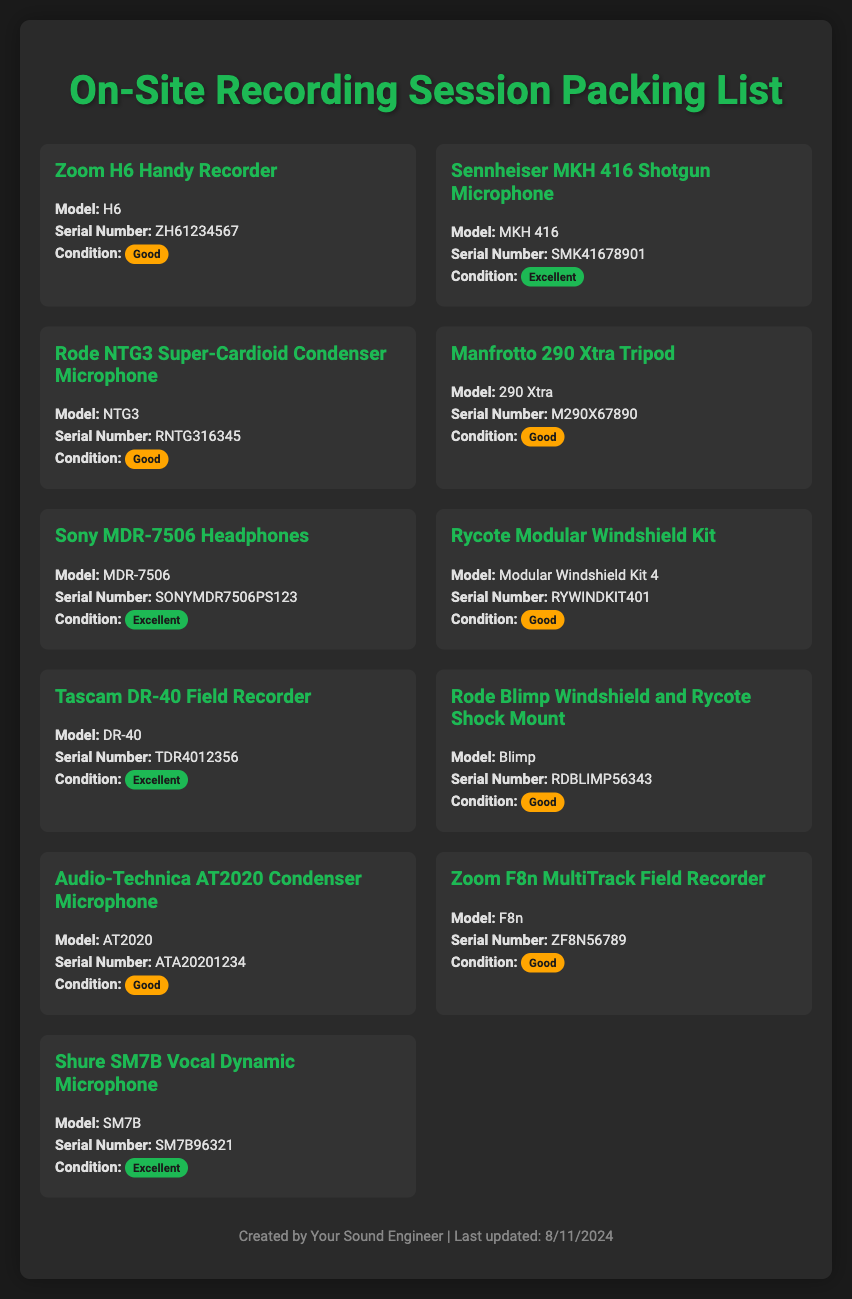what is the model of the shotgun microphone? The document lists "Sennheiser MKH 416 Shotgun Microphone" with its model specified as "MKH 416."
Answer: MKH 416 what is the serial number of the Rode NTG3 microphone? The Rode NTG3 microphone has a serial number mentioned in the document, which is "RNTG316345."
Answer: RNTG316345 how many items are listed in total? The document includes a grid of equipment items, specifically ten items total.
Answer: 10 which item's condition is rated as excellent? The Shure SM7B Vocal Dynamic Microphone has its condition labeled as excellent in the document.
Answer: Shure SM7B what is the condition of the Zoom H6 Handy Recorder? The condition of the Zoom H6 Handy Recorder is specified as "Good" in the document.
Answer: Good which piece of equipment has the serial number ZH61234567? The serial number "ZH61234567" corresponds to the Zoom H6 Handy Recorder as per the document.
Answer: Zoom H6 Handy Recorder which item has the condition "Good" and is a tripod? "Manfrotto 290 Xtra Tripod" is the item listed in good condition in the document.
Answer: Manfrotto 290 Xtra Tripod what is the model of the field recorder listed? The model of the field recorder specified in the document is "DR-40."
Answer: DR-40 how many microphones are listed in the equipment inventory? The document lists five microphones as part of the equipment inventory.
Answer: 5 